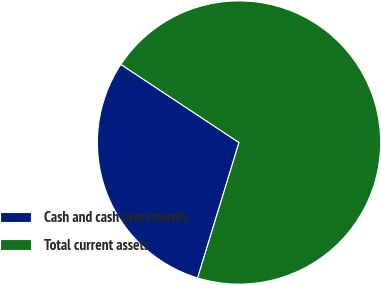<chart> <loc_0><loc_0><loc_500><loc_500><pie_chart><fcel>Cash and cash investments<fcel>Total current assets<nl><fcel>29.58%<fcel>70.42%<nl></chart> 